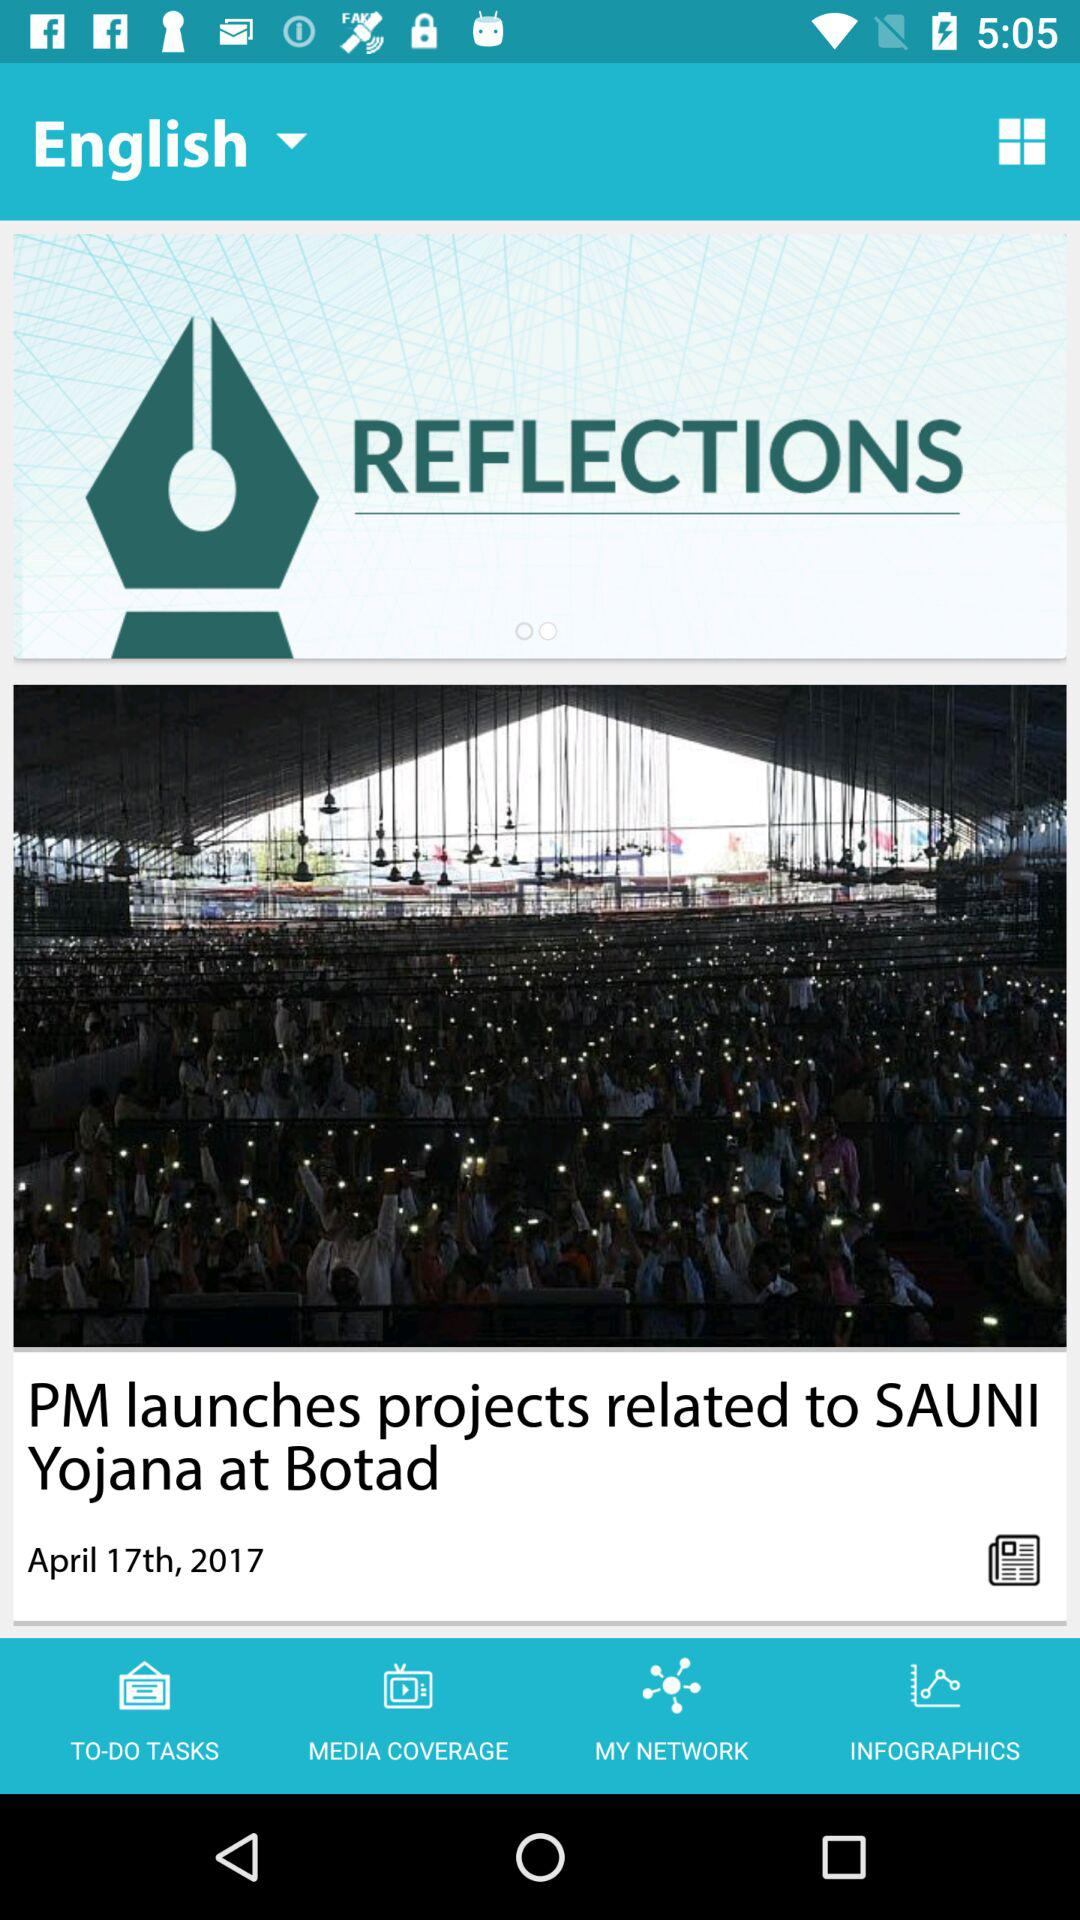What is the news date? The news date is April 17th, 2017. 